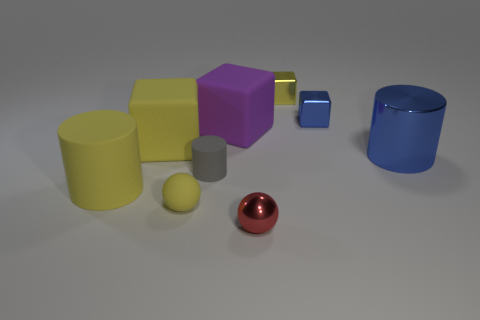Subtract all small gray rubber cylinders. How many cylinders are left? 2 Subtract all red spheres. How many yellow blocks are left? 2 Subtract 1 cylinders. How many cylinders are left? 2 Subtract all blue cubes. How many cubes are left? 3 Add 1 matte balls. How many objects exist? 10 Subtract all brown blocks. Subtract all red balls. How many blocks are left? 4 Subtract all blocks. How many objects are left? 5 Subtract all tiny purple metallic cylinders. Subtract all small gray rubber cylinders. How many objects are left? 8 Add 6 large yellow matte things. How many large yellow matte things are left? 8 Add 7 small rubber balls. How many small rubber balls exist? 8 